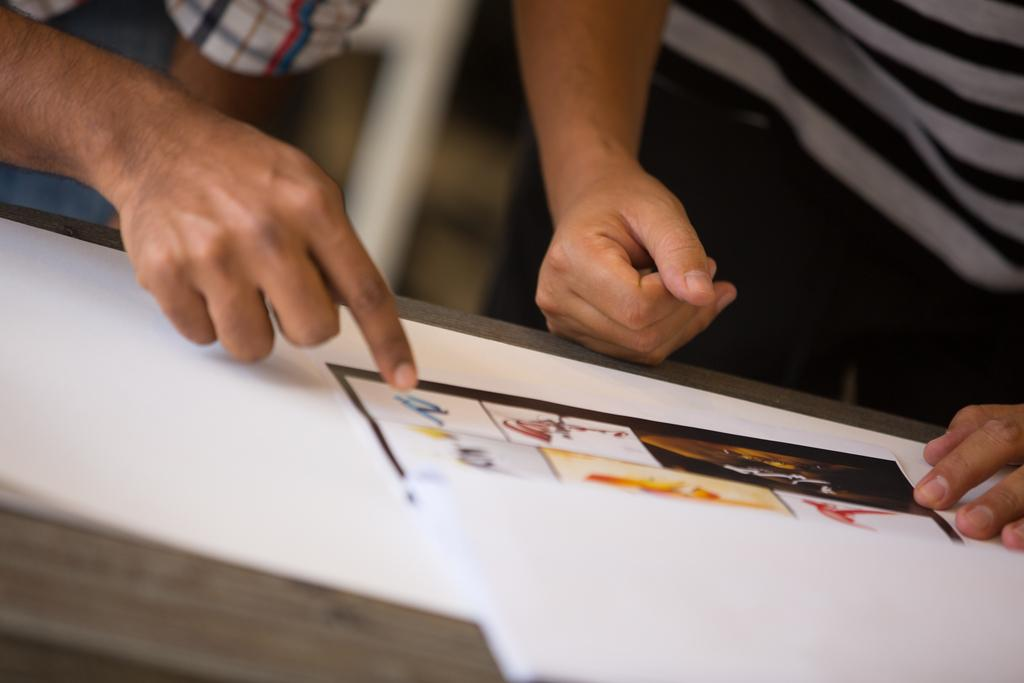How many people are in the image? There are two persons standing in the image. What can be seen in the image besides the people? There is a table in the image. What is on the table? Papers are present on the table. Can you describe the background of the image? The background of the image is blurred. What type of ink can be seen on the gloves in the image? There are no gloves present in the image, so there is no ink to be seen on them. 